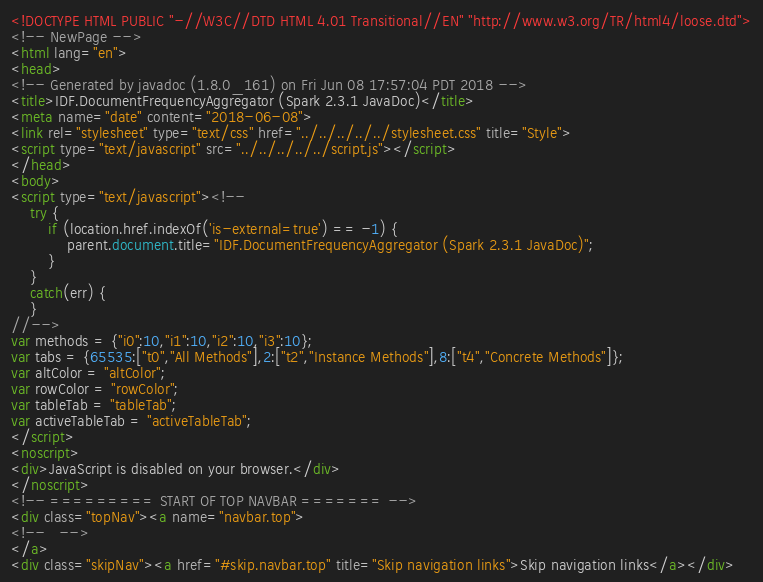<code> <loc_0><loc_0><loc_500><loc_500><_HTML_><!DOCTYPE HTML PUBLIC "-//W3C//DTD HTML 4.01 Transitional//EN" "http://www.w3.org/TR/html4/loose.dtd">
<!-- NewPage -->
<html lang="en">
<head>
<!-- Generated by javadoc (1.8.0_161) on Fri Jun 08 17:57:04 PDT 2018 -->
<title>IDF.DocumentFrequencyAggregator (Spark 2.3.1 JavaDoc)</title>
<meta name="date" content="2018-06-08">
<link rel="stylesheet" type="text/css" href="../../../../../stylesheet.css" title="Style">
<script type="text/javascript" src="../../../../../script.js"></script>
</head>
<body>
<script type="text/javascript"><!--
    try {
        if (location.href.indexOf('is-external=true') == -1) {
            parent.document.title="IDF.DocumentFrequencyAggregator (Spark 2.3.1 JavaDoc)";
        }
    }
    catch(err) {
    }
//-->
var methods = {"i0":10,"i1":10,"i2":10,"i3":10};
var tabs = {65535:["t0","All Methods"],2:["t2","Instance Methods"],8:["t4","Concrete Methods"]};
var altColor = "altColor";
var rowColor = "rowColor";
var tableTab = "tableTab";
var activeTableTab = "activeTableTab";
</script>
<noscript>
<div>JavaScript is disabled on your browser.</div>
</noscript>
<!-- ========= START OF TOP NAVBAR ======= -->
<div class="topNav"><a name="navbar.top">
<!--   -->
</a>
<div class="skipNav"><a href="#skip.navbar.top" title="Skip navigation links">Skip navigation links</a></div></code> 